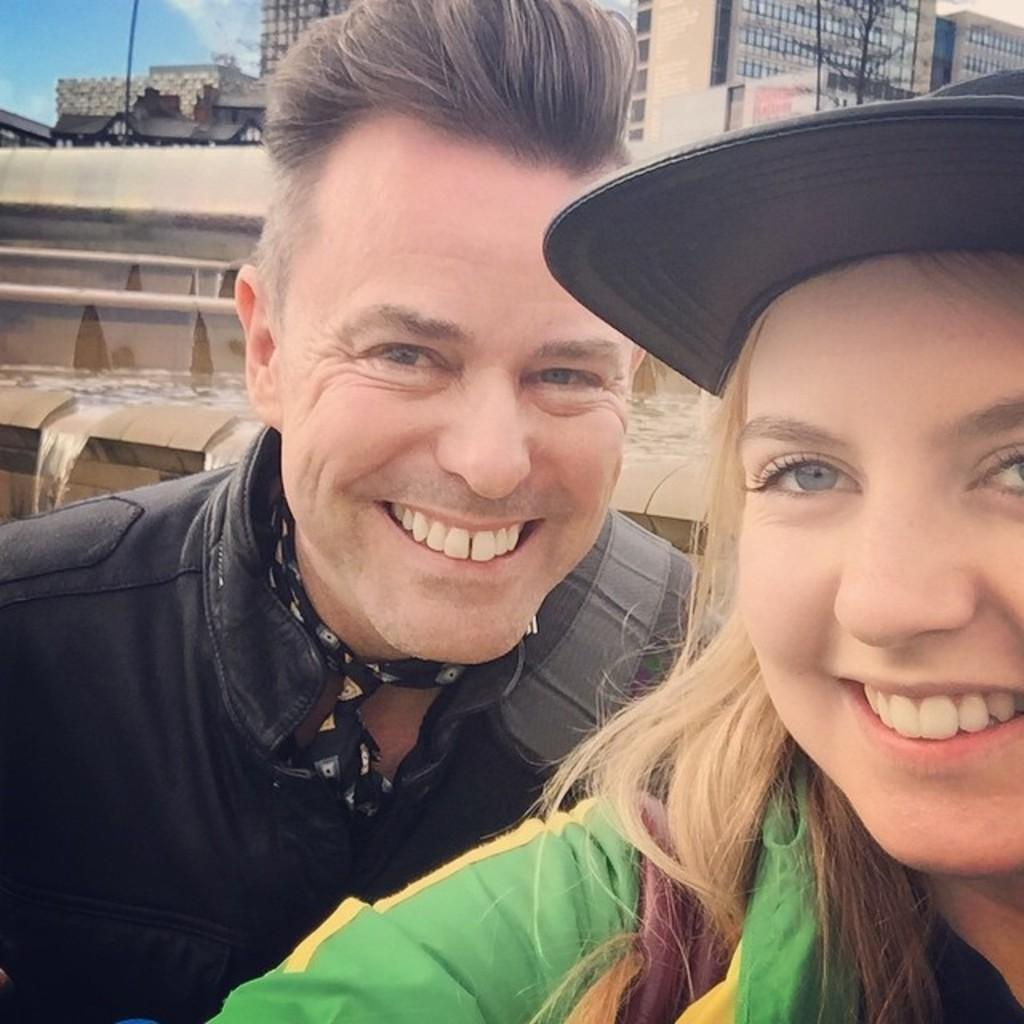Who are the people in the image? There is a man and a woman in the image. What expressions do the people have? Both the man and the woman are smiling. What can be seen in the foreground of the image? There is water flowing in the image. What is visible in the background of the image? There are buildings and a tree visible in the image. What is the dad doing in the image? There is no dad present in the image, as the only people mentioned are a man and a woman. How does the grandmother interact with the tree in the image? There is no grandmother present in the image, and therefore no interaction with the tree can be observed. 